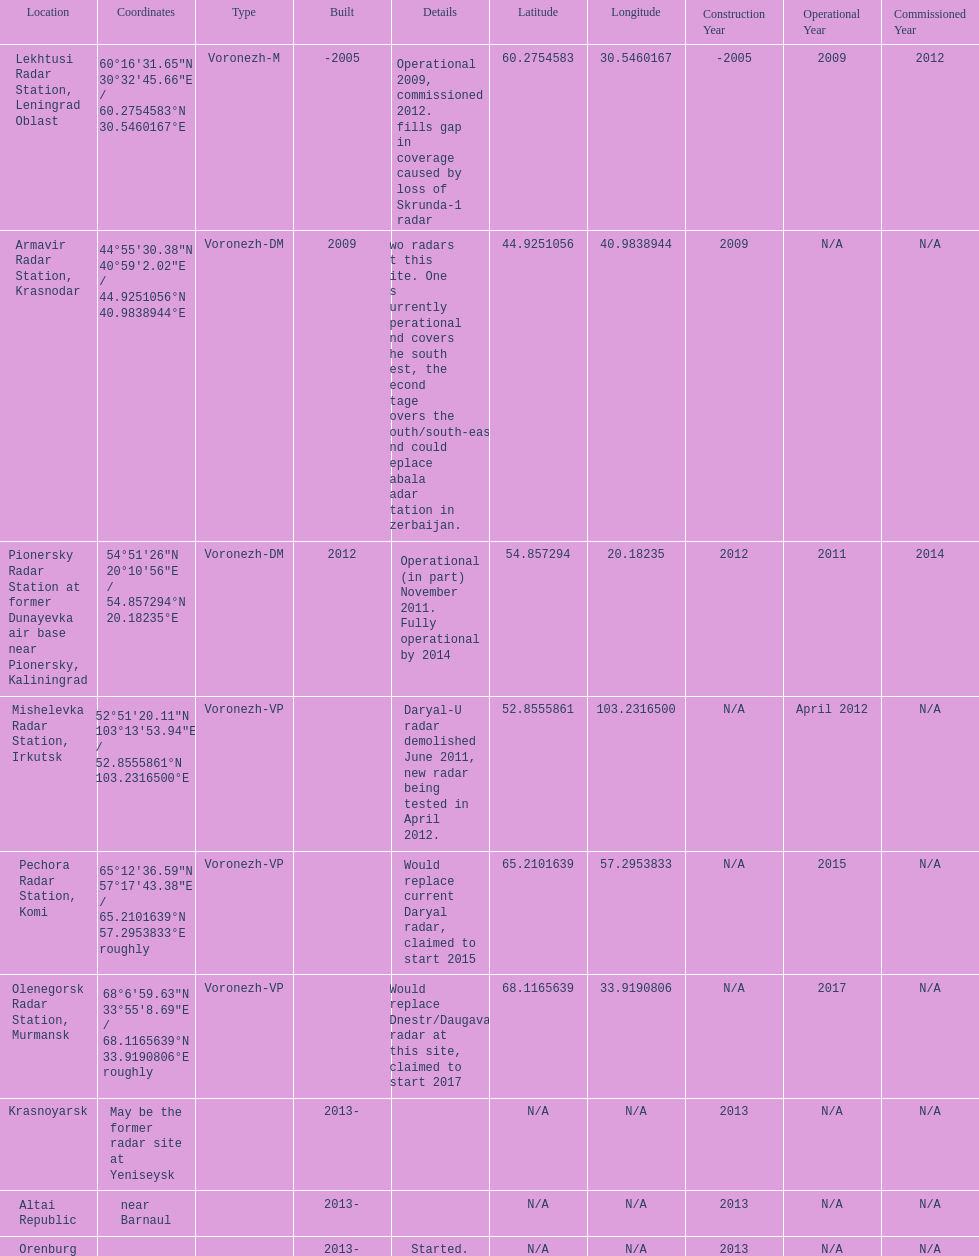How long did it take the pionersky radar station to go from partially operational to fully operational? 3 years. 